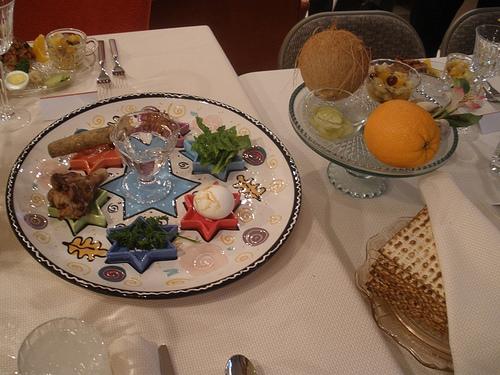Has the coconut been opened?
Keep it brief. No. What types of fruit are on the table?
Keep it brief. Orange and coconut. Does the left plate have stars on it?
Write a very short answer. Yes. How many oranges are in the bowl?
Quick response, please. 1. What color are the plates?
Give a very brief answer. White. 